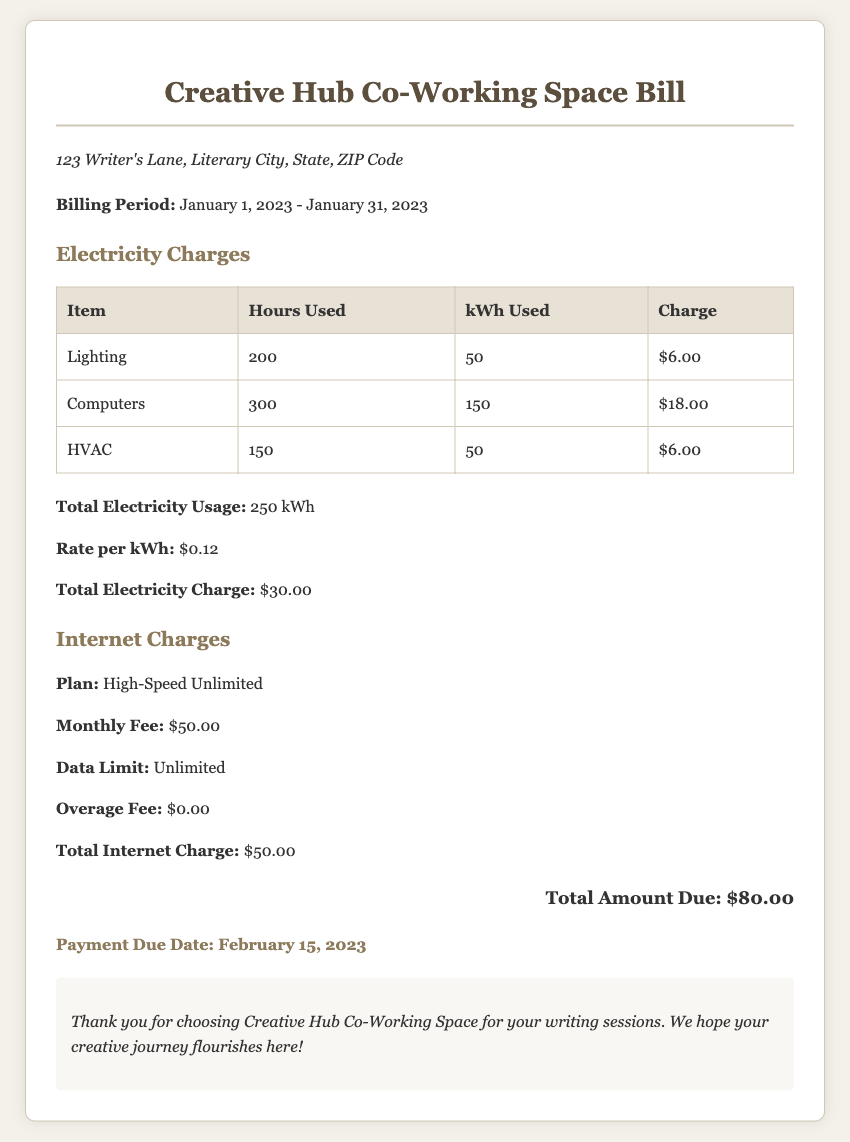What is the billing period? The billing period is specified in the document as January 1, 2023 - January 31, 2023.
Answer: January 1, 2023 - January 31, 2023 What is the total electricity charge? The total electricity charge is clearly mentioned in the document, which sums up the electricity usage.
Answer: $30.00 How many kWh were used for computers? The document provides specific information about the kWh used for computers, which is necessary to ascertain.
Answer: 150 What is the plan for internet service? The internet service plan is detailed in the bill and reveals the type of service subscribed to.
Answer: High-Speed Unlimited What is the total amount due? The total amount due is prominently displayed at the bottom of the bill, combining all charges.
Answer: $80.00 How many hours were used for lighting? The hours used for lighting are specified in the breakdown of electricity charges.
Answer: 200 What is the rate per kWh? The rate per kWh is given in the electricity section of the bill, providing essential cost information.
Answer: $0.12 What is the payment due date? The payment due date is indicated at the end of the document, important for payment scheduling.
Answer: February 15, 2023 What is the monthly fee for internet service? The document specifies the monthly fee, crucial for understanding internet costs associated with the co-working space.
Answer: $50.00 